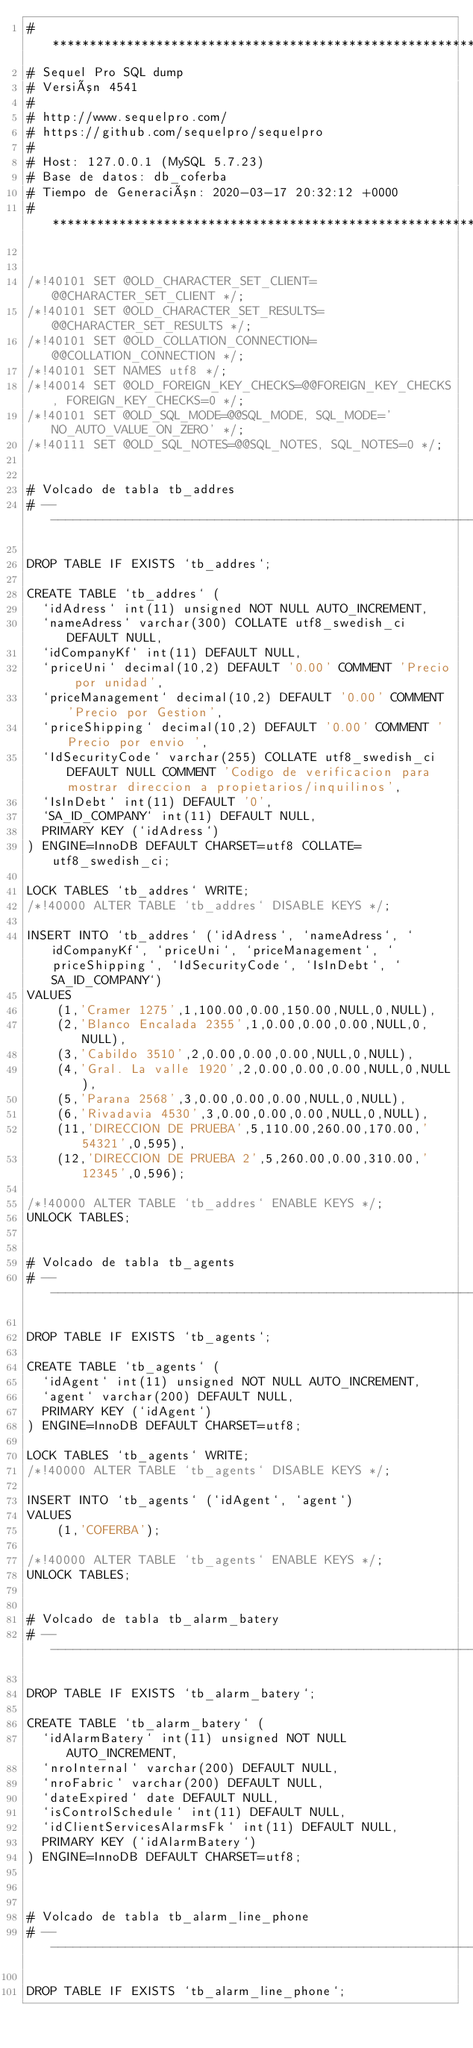<code> <loc_0><loc_0><loc_500><loc_500><_SQL_># ************************************************************
# Sequel Pro SQL dump
# Versión 4541
#
# http://www.sequelpro.com/
# https://github.com/sequelpro/sequelpro
#
# Host: 127.0.0.1 (MySQL 5.7.23)
# Base de datos: db_coferba
# Tiempo de Generación: 2020-03-17 20:32:12 +0000
# ************************************************************


/*!40101 SET @OLD_CHARACTER_SET_CLIENT=@@CHARACTER_SET_CLIENT */;
/*!40101 SET @OLD_CHARACTER_SET_RESULTS=@@CHARACTER_SET_RESULTS */;
/*!40101 SET @OLD_COLLATION_CONNECTION=@@COLLATION_CONNECTION */;
/*!40101 SET NAMES utf8 */;
/*!40014 SET @OLD_FOREIGN_KEY_CHECKS=@@FOREIGN_KEY_CHECKS, FOREIGN_KEY_CHECKS=0 */;
/*!40101 SET @OLD_SQL_MODE=@@SQL_MODE, SQL_MODE='NO_AUTO_VALUE_ON_ZERO' */;
/*!40111 SET @OLD_SQL_NOTES=@@SQL_NOTES, SQL_NOTES=0 */;


# Volcado de tabla tb_addres
# ------------------------------------------------------------

DROP TABLE IF EXISTS `tb_addres`;

CREATE TABLE `tb_addres` (
  `idAdress` int(11) unsigned NOT NULL AUTO_INCREMENT,
  `nameAdress` varchar(300) COLLATE utf8_swedish_ci DEFAULT NULL,
  `idCompanyKf` int(11) DEFAULT NULL,
  `priceUni` decimal(10,2) DEFAULT '0.00' COMMENT 'Precio por unidad',
  `priceManagement` decimal(10,2) DEFAULT '0.00' COMMENT 'Precio por Gestion',
  `priceShipping` decimal(10,2) DEFAULT '0.00' COMMENT 'Precio por envio ',
  `IdSecurityCode` varchar(255) COLLATE utf8_swedish_ci DEFAULT NULL COMMENT 'Codigo de verificacion para mostrar direccion a propietarios/inquilinos',
  `IsInDebt` int(11) DEFAULT '0',
  `SA_ID_COMPANY` int(11) DEFAULT NULL,
  PRIMARY KEY (`idAdress`)
) ENGINE=InnoDB DEFAULT CHARSET=utf8 COLLATE=utf8_swedish_ci;

LOCK TABLES `tb_addres` WRITE;
/*!40000 ALTER TABLE `tb_addres` DISABLE KEYS */;

INSERT INTO `tb_addres` (`idAdress`, `nameAdress`, `idCompanyKf`, `priceUni`, `priceManagement`, `priceShipping`, `IdSecurityCode`, `IsInDebt`, `SA_ID_COMPANY`)
VALUES
	(1,'Cramer 1275',1,100.00,0.00,150.00,NULL,0,NULL),
	(2,'Blanco Encalada 2355',1,0.00,0.00,0.00,NULL,0,NULL),
	(3,'Cabildo 3510',2,0.00,0.00,0.00,NULL,0,NULL),
	(4,'Gral. La valle 1920',2,0.00,0.00,0.00,NULL,0,NULL),
	(5,'Parana 2568',3,0.00,0.00,0.00,NULL,0,NULL),
	(6,'Rivadavia 4530',3,0.00,0.00,0.00,NULL,0,NULL),
	(11,'DIRECCION DE PRUEBA',5,110.00,260.00,170.00,'54321',0,595),
	(12,'DIRECCION DE PRUEBA 2',5,260.00,0.00,310.00,'12345',0,596);

/*!40000 ALTER TABLE `tb_addres` ENABLE KEYS */;
UNLOCK TABLES;


# Volcado de tabla tb_agents
# ------------------------------------------------------------

DROP TABLE IF EXISTS `tb_agents`;

CREATE TABLE `tb_agents` (
  `idAgent` int(11) unsigned NOT NULL AUTO_INCREMENT,
  `agent` varchar(200) DEFAULT NULL,
  PRIMARY KEY (`idAgent`)
) ENGINE=InnoDB DEFAULT CHARSET=utf8;

LOCK TABLES `tb_agents` WRITE;
/*!40000 ALTER TABLE `tb_agents` DISABLE KEYS */;

INSERT INTO `tb_agents` (`idAgent`, `agent`)
VALUES
	(1,'COFERBA');

/*!40000 ALTER TABLE `tb_agents` ENABLE KEYS */;
UNLOCK TABLES;


# Volcado de tabla tb_alarm_batery
# ------------------------------------------------------------

DROP TABLE IF EXISTS `tb_alarm_batery`;

CREATE TABLE `tb_alarm_batery` (
  `idAlarmBatery` int(11) unsigned NOT NULL AUTO_INCREMENT,
  `nroInternal` varchar(200) DEFAULT NULL,
  `nroFabric` varchar(200) DEFAULT NULL,
  `dateExpired` date DEFAULT NULL,
  `isControlSchedule` int(11) DEFAULT NULL,
  `idClientServicesAlarmsFk` int(11) DEFAULT NULL,
  PRIMARY KEY (`idAlarmBatery`)
) ENGINE=InnoDB DEFAULT CHARSET=utf8;



# Volcado de tabla tb_alarm_line_phone
# ------------------------------------------------------------

DROP TABLE IF EXISTS `tb_alarm_line_phone`;
</code> 